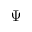Convert formula to latex. <formula><loc_0><loc_0><loc_500><loc_500>\Psi</formula> 